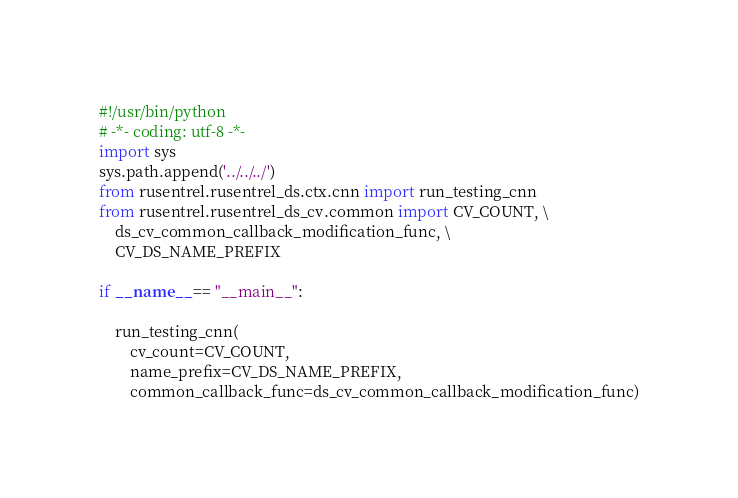<code> <loc_0><loc_0><loc_500><loc_500><_Python_>#!/usr/bin/python
# -*- coding: utf-8 -*-
import sys
sys.path.append('../../../')
from rusentrel.rusentrel_ds.ctx.cnn import run_testing_cnn
from rusentrel.rusentrel_ds_cv.common import CV_COUNT, \
    ds_cv_common_callback_modification_func, \
    CV_DS_NAME_PREFIX

if __name__ == "__main__":

    run_testing_cnn(
        cv_count=CV_COUNT,
        name_prefix=CV_DS_NAME_PREFIX,
        common_callback_func=ds_cv_common_callback_modification_func)
</code> 